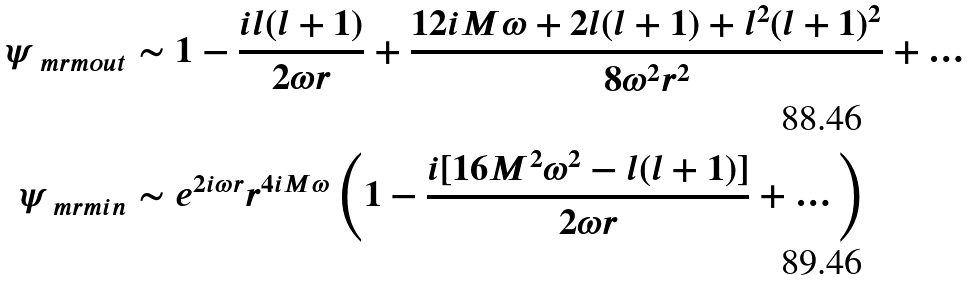<formula> <loc_0><loc_0><loc_500><loc_500>\psi _ { \ m r m { o u t } } & \sim 1 - \frac { i l ( l + 1 ) } { 2 \omega r } + \frac { 1 2 i M \omega + 2 l ( l + 1 ) + l ^ { 2 } ( l + 1 ) ^ { 2 } } { 8 \omega ^ { 2 } r ^ { 2 } } + \dots \\ \psi _ { \ m r m { i n } } & \sim e ^ { 2 i \omega r } r ^ { 4 i M \omega } \left ( 1 - \frac { i [ 1 6 M ^ { 2 } \omega ^ { 2 } - l ( l + 1 ) ] } { 2 \omega r } + \dots \right )</formula> 